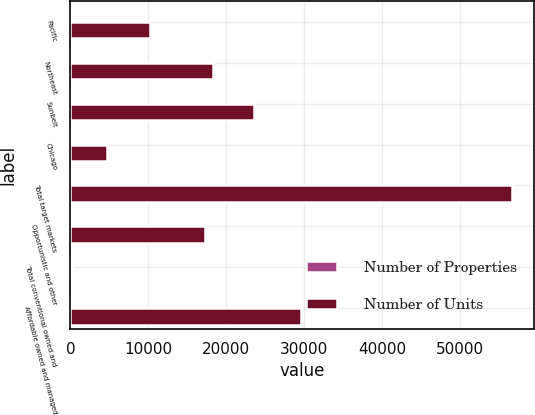Convert chart to OTSL. <chart><loc_0><loc_0><loc_500><loc_500><stacked_bar_chart><ecel><fcel>Pacific<fcel>Northeast<fcel>Sunbelt<fcel>Chicago<fcel>Total target markets<fcel>Opportunistic and other<fcel>Total conventional owned and<fcel>Affordable owned and managed<nl><fcel>Number of Properties<fcel>37<fcel>62<fcel>77<fcel>15<fcel>191<fcel>52<fcel>243<fcel>260<nl><fcel>Number of Units<fcel>10274<fcel>18270<fcel>23546<fcel>4633<fcel>56723<fcel>17307<fcel>260<fcel>29650<nl></chart> 